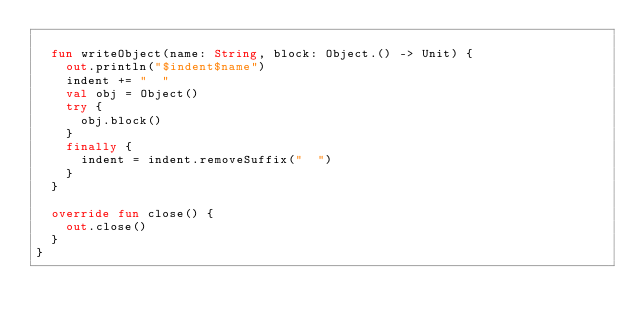Convert code to text. <code><loc_0><loc_0><loc_500><loc_500><_Kotlin_>
  fun writeObject(name: String, block: Object.() -> Unit) {
    out.println("$indent$name")
    indent += "  "
    val obj = Object()
    try {
      obj.block()
    }
    finally {
      indent = indent.removeSuffix("  ")
    }
  }

  override fun close() {
    out.close()
  }
}</code> 